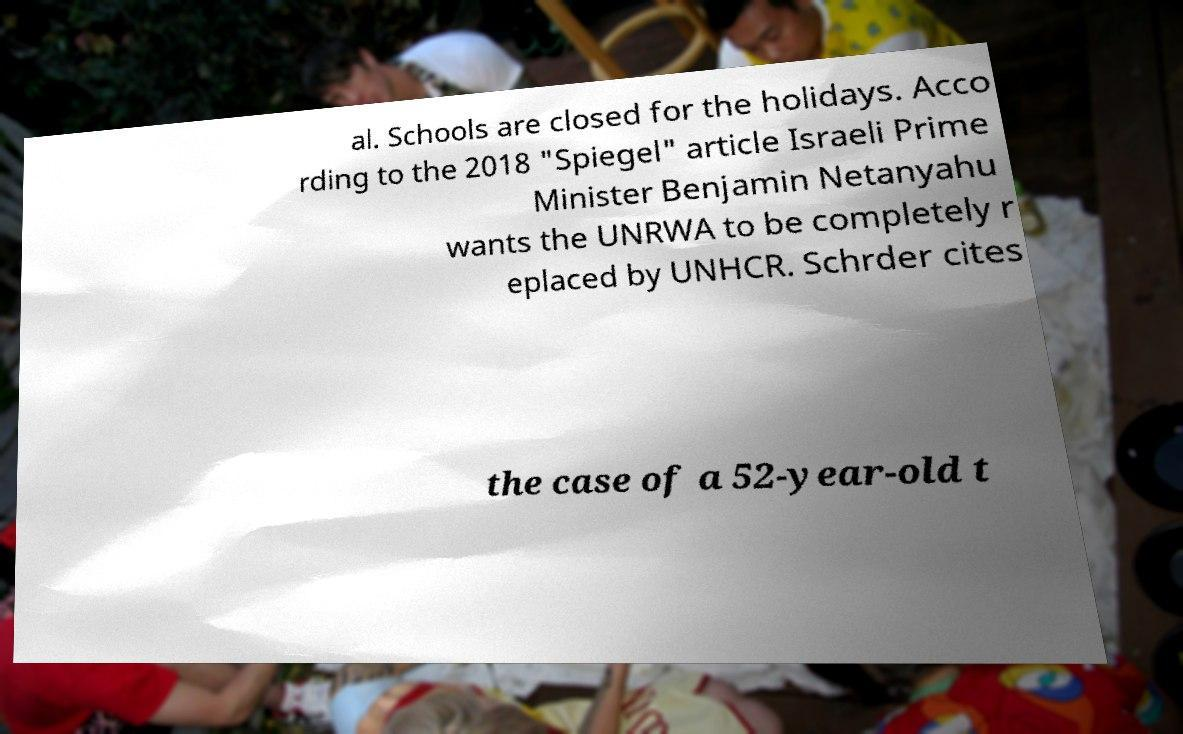Please read and relay the text visible in this image. What does it say? al. Schools are closed for the holidays. Acco rding to the 2018 "Spiegel" article Israeli Prime Minister Benjamin Netanyahu wants the UNRWA to be completely r eplaced by UNHCR. Schrder cites the case of a 52-year-old t 